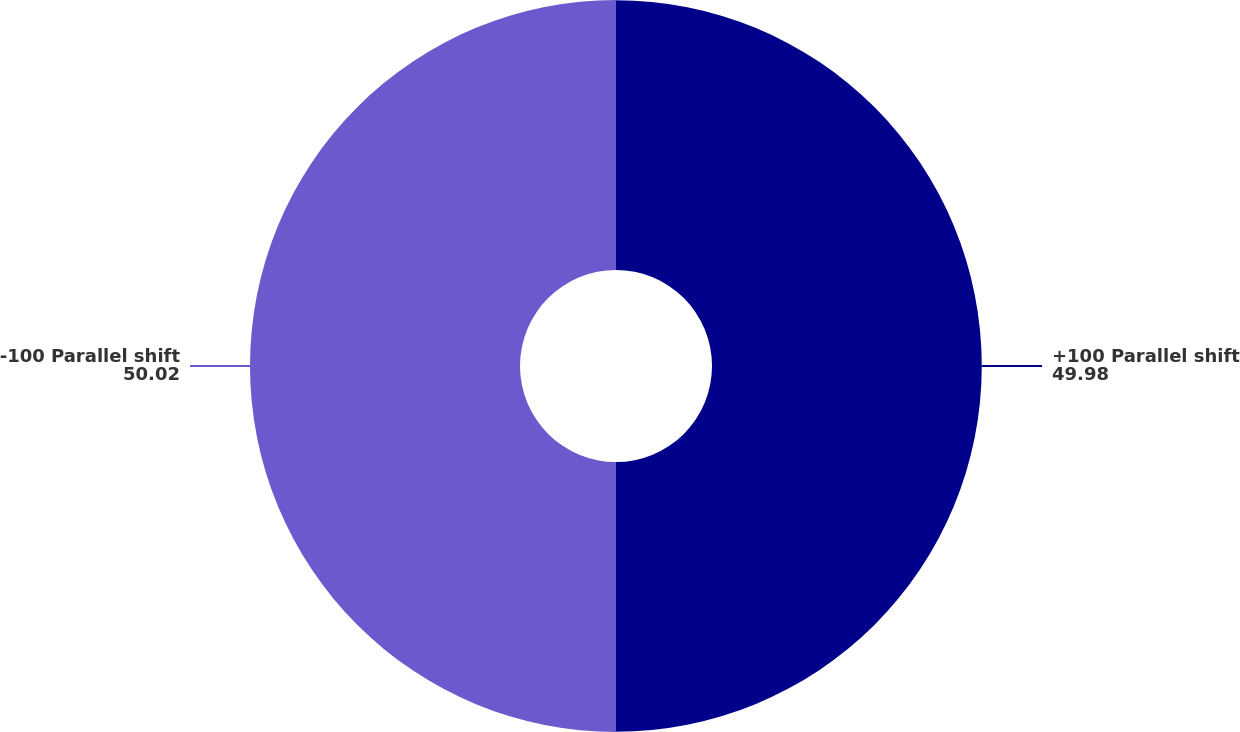Convert chart to OTSL. <chart><loc_0><loc_0><loc_500><loc_500><pie_chart><fcel>+100 Parallel shift<fcel>-100 Parallel shift<nl><fcel>49.98%<fcel>50.02%<nl></chart> 